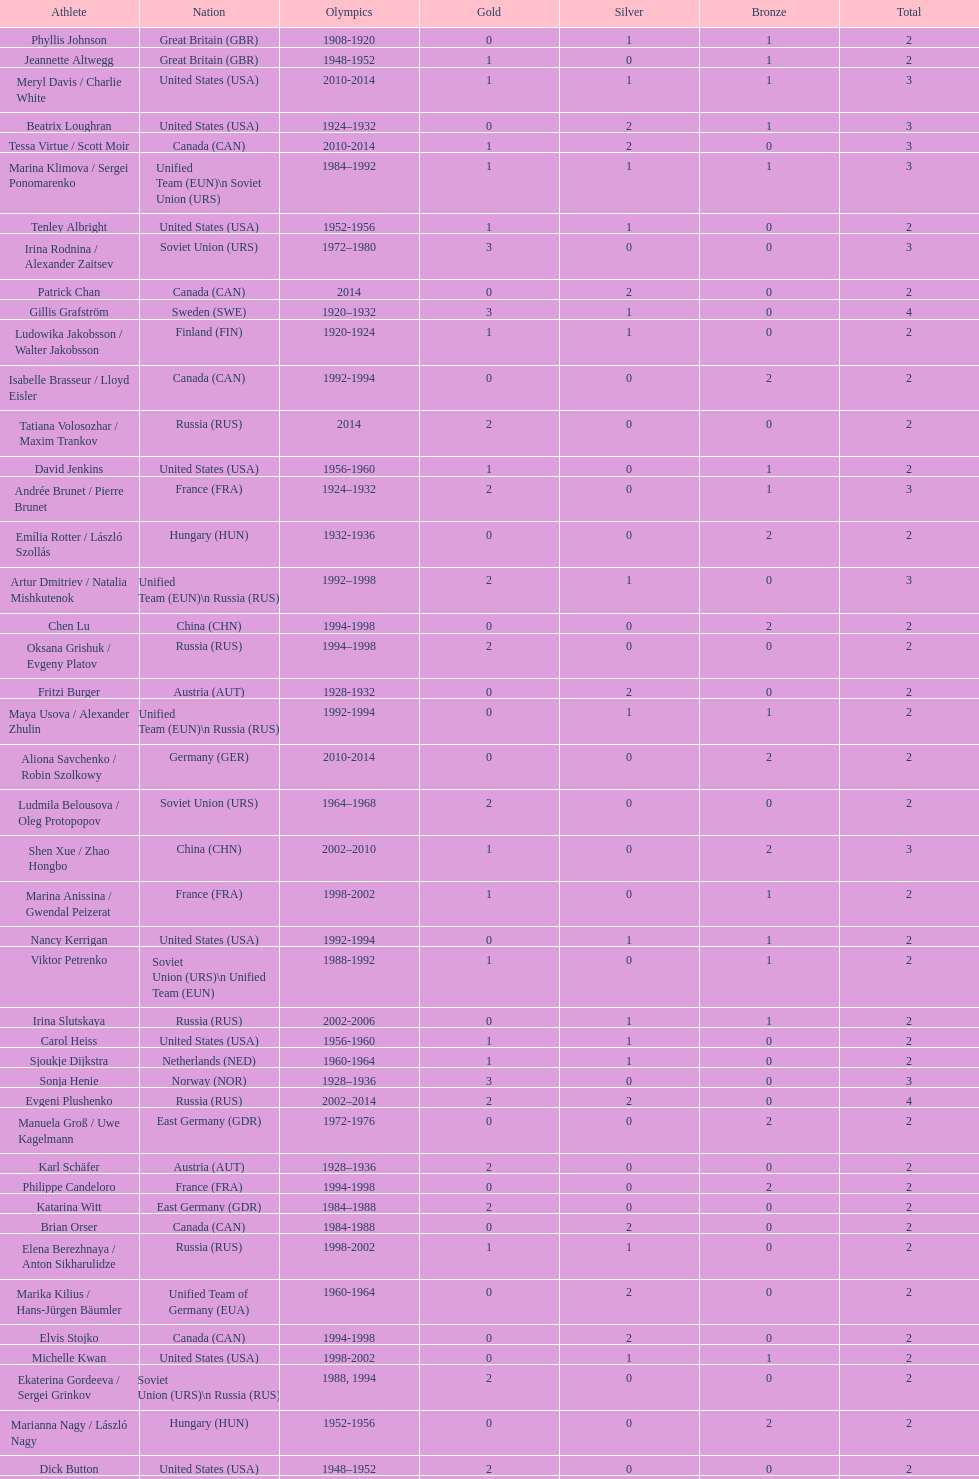How many more silver medals did gillis grafström have compared to sonja henie? 1. 